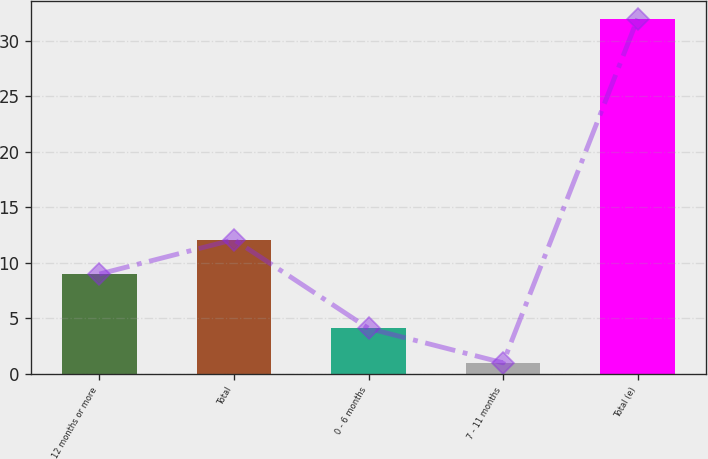Convert chart to OTSL. <chart><loc_0><loc_0><loc_500><loc_500><bar_chart><fcel>12 months or more<fcel>Total<fcel>0 - 6 months<fcel>7 - 11 months<fcel>Total (e)<nl><fcel>9<fcel>12.1<fcel>4.1<fcel>1<fcel>32<nl></chart> 